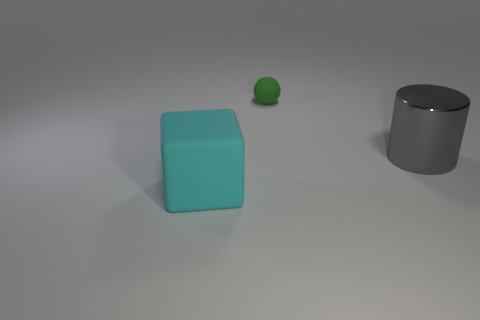What is the shape of the gray metal thing that is the same size as the cyan block? cylinder 